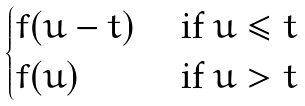<formula> <loc_0><loc_0><loc_500><loc_500>\begin{cases} f ( u - t ) & \text { if } u \leq t \\ f ( u ) & \text { if } u > t \end{cases}</formula> 